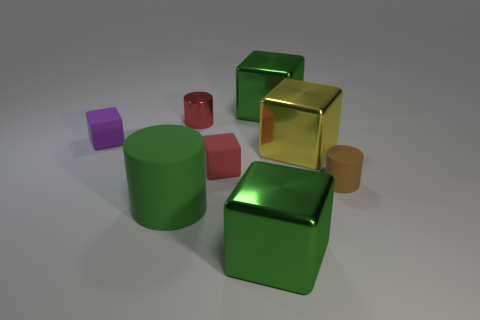Are there more rubber blocks that are on the right side of the green matte cylinder than large green rubber objects?
Offer a terse response. No. What number of objects are either green metallic blocks that are behind the green cylinder or large cyan cylinders?
Offer a terse response. 1. What number of cylinders are made of the same material as the large yellow block?
Offer a very short reply. 1. There is a small rubber object that is the same color as the tiny metallic cylinder; what is its shape?
Your answer should be very brief. Cube. Is there a small red metallic object that has the same shape as the red rubber object?
Provide a succinct answer. No. There is a matte object that is the same size as the yellow metallic cube; what shape is it?
Keep it short and to the point. Cylinder. Does the small metallic object have the same color as the matte cylinder on the left side of the tiny brown cylinder?
Your answer should be compact. No. There is a large object behind the purple matte block; what number of green cylinders are behind it?
Your answer should be very brief. 0. How big is the matte thing that is both in front of the tiny red cube and on the left side of the brown rubber object?
Provide a short and direct response. Large. Is there a brown cylinder that has the same size as the yellow metallic thing?
Offer a very short reply. No. 